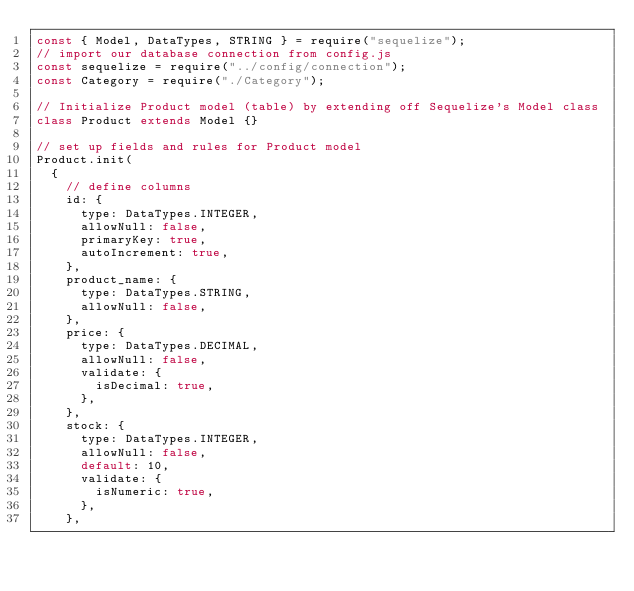Convert code to text. <code><loc_0><loc_0><loc_500><loc_500><_JavaScript_>const { Model, DataTypes, STRING } = require("sequelize");
// import our database connection from config.js
const sequelize = require("../config/connection");
const Category = require("./Category");

// Initialize Product model (table) by extending off Sequelize's Model class
class Product extends Model {}

// set up fields and rules for Product model
Product.init(
  {
    // define columns
    id: {
      type: DataTypes.INTEGER,
      allowNull: false,
      primaryKey: true,
      autoIncrement: true,
    },
    product_name: {
      type: DataTypes.STRING,
      allowNull: false,
    },
    price: {
      type: DataTypes.DECIMAL,
      allowNull: false,
      validate: {
        isDecimal: true,
      },
    },
    stock: {
      type: DataTypes.INTEGER,
      allowNull: false,
      default: 10,
      validate: {
        isNumeric: true,
      },
    },</code> 